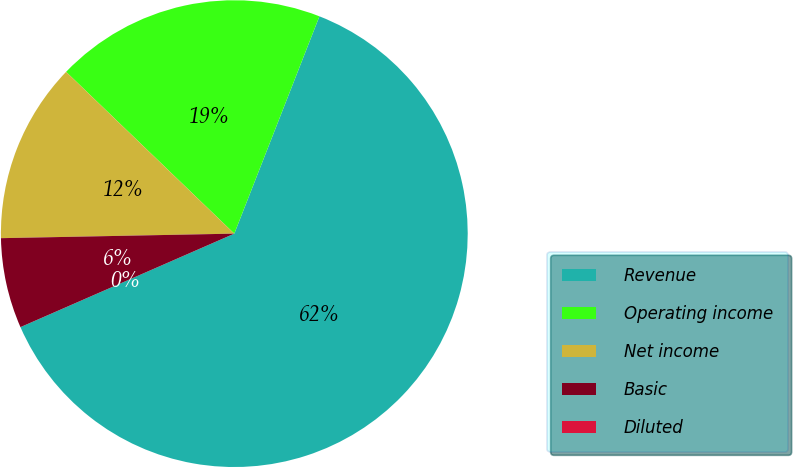Convert chart. <chart><loc_0><loc_0><loc_500><loc_500><pie_chart><fcel>Revenue<fcel>Operating income<fcel>Net income<fcel>Basic<fcel>Diluted<nl><fcel>62.5%<fcel>18.75%<fcel>12.5%<fcel>6.25%<fcel>0.0%<nl></chart> 